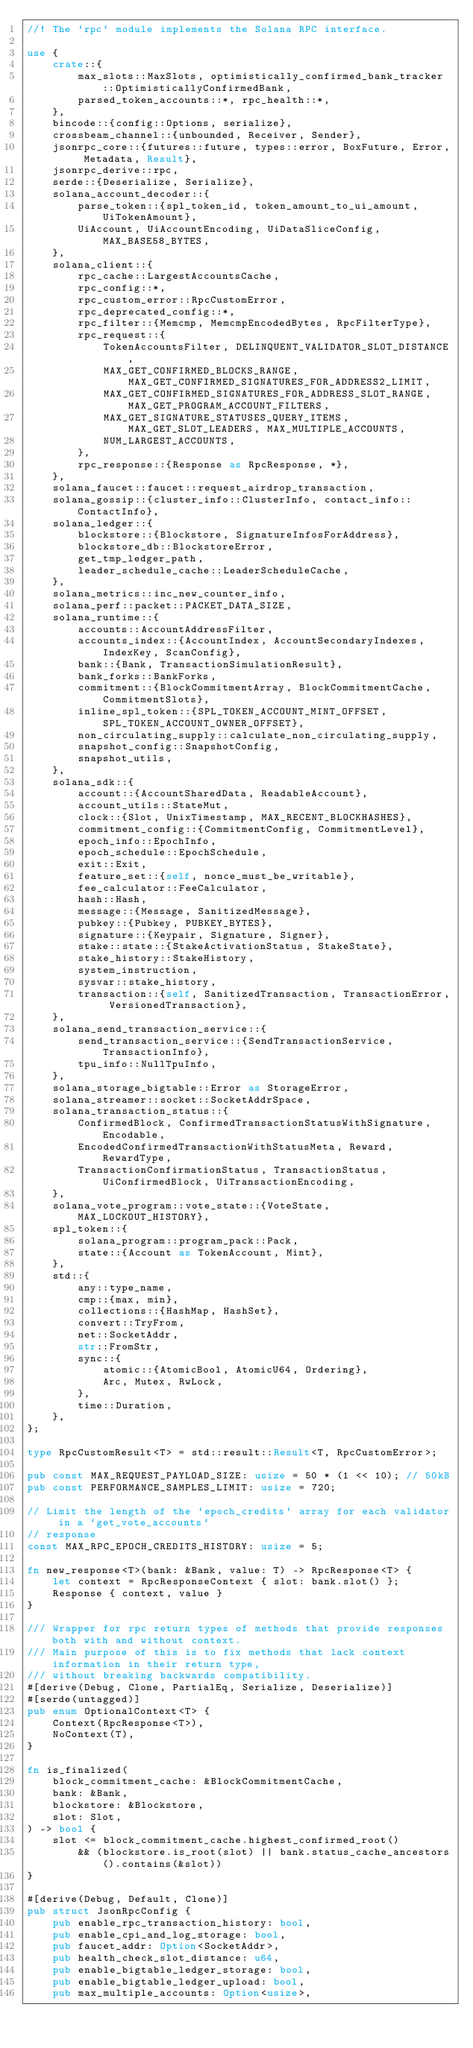Convert code to text. <code><loc_0><loc_0><loc_500><loc_500><_Rust_>//! The `rpc` module implements the Solana RPC interface.

use {
    crate::{
        max_slots::MaxSlots, optimistically_confirmed_bank_tracker::OptimisticallyConfirmedBank,
        parsed_token_accounts::*, rpc_health::*,
    },
    bincode::{config::Options, serialize},
    crossbeam_channel::{unbounded, Receiver, Sender},
    jsonrpc_core::{futures::future, types::error, BoxFuture, Error, Metadata, Result},
    jsonrpc_derive::rpc,
    serde::{Deserialize, Serialize},
    solana_account_decoder::{
        parse_token::{spl_token_id, token_amount_to_ui_amount, UiTokenAmount},
        UiAccount, UiAccountEncoding, UiDataSliceConfig, MAX_BASE58_BYTES,
    },
    solana_client::{
        rpc_cache::LargestAccountsCache,
        rpc_config::*,
        rpc_custom_error::RpcCustomError,
        rpc_deprecated_config::*,
        rpc_filter::{Memcmp, MemcmpEncodedBytes, RpcFilterType},
        rpc_request::{
            TokenAccountsFilter, DELINQUENT_VALIDATOR_SLOT_DISTANCE,
            MAX_GET_CONFIRMED_BLOCKS_RANGE, MAX_GET_CONFIRMED_SIGNATURES_FOR_ADDRESS2_LIMIT,
            MAX_GET_CONFIRMED_SIGNATURES_FOR_ADDRESS_SLOT_RANGE, MAX_GET_PROGRAM_ACCOUNT_FILTERS,
            MAX_GET_SIGNATURE_STATUSES_QUERY_ITEMS, MAX_GET_SLOT_LEADERS, MAX_MULTIPLE_ACCOUNTS,
            NUM_LARGEST_ACCOUNTS,
        },
        rpc_response::{Response as RpcResponse, *},
    },
    solana_faucet::faucet::request_airdrop_transaction,
    solana_gossip::{cluster_info::ClusterInfo, contact_info::ContactInfo},
    solana_ledger::{
        blockstore::{Blockstore, SignatureInfosForAddress},
        blockstore_db::BlockstoreError,
        get_tmp_ledger_path,
        leader_schedule_cache::LeaderScheduleCache,
    },
    solana_metrics::inc_new_counter_info,
    solana_perf::packet::PACKET_DATA_SIZE,
    solana_runtime::{
        accounts::AccountAddressFilter,
        accounts_index::{AccountIndex, AccountSecondaryIndexes, IndexKey, ScanConfig},
        bank::{Bank, TransactionSimulationResult},
        bank_forks::BankForks,
        commitment::{BlockCommitmentArray, BlockCommitmentCache, CommitmentSlots},
        inline_spl_token::{SPL_TOKEN_ACCOUNT_MINT_OFFSET, SPL_TOKEN_ACCOUNT_OWNER_OFFSET},
        non_circulating_supply::calculate_non_circulating_supply,
        snapshot_config::SnapshotConfig,
        snapshot_utils,
    },
    solana_sdk::{
        account::{AccountSharedData, ReadableAccount},
        account_utils::StateMut,
        clock::{Slot, UnixTimestamp, MAX_RECENT_BLOCKHASHES},
        commitment_config::{CommitmentConfig, CommitmentLevel},
        epoch_info::EpochInfo,
        epoch_schedule::EpochSchedule,
        exit::Exit,
        feature_set::{self, nonce_must_be_writable},
        fee_calculator::FeeCalculator,
        hash::Hash,
        message::{Message, SanitizedMessage},
        pubkey::{Pubkey, PUBKEY_BYTES},
        signature::{Keypair, Signature, Signer},
        stake::state::{StakeActivationStatus, StakeState},
        stake_history::StakeHistory,
        system_instruction,
        sysvar::stake_history,
        transaction::{self, SanitizedTransaction, TransactionError, VersionedTransaction},
    },
    solana_send_transaction_service::{
        send_transaction_service::{SendTransactionService, TransactionInfo},
        tpu_info::NullTpuInfo,
    },
    solana_storage_bigtable::Error as StorageError,
    solana_streamer::socket::SocketAddrSpace,
    solana_transaction_status::{
        ConfirmedBlock, ConfirmedTransactionStatusWithSignature, Encodable,
        EncodedConfirmedTransactionWithStatusMeta, Reward, RewardType,
        TransactionConfirmationStatus, TransactionStatus, UiConfirmedBlock, UiTransactionEncoding,
    },
    solana_vote_program::vote_state::{VoteState, MAX_LOCKOUT_HISTORY},
    spl_token::{
        solana_program::program_pack::Pack,
        state::{Account as TokenAccount, Mint},
    },
    std::{
        any::type_name,
        cmp::{max, min},
        collections::{HashMap, HashSet},
        convert::TryFrom,
        net::SocketAddr,
        str::FromStr,
        sync::{
            atomic::{AtomicBool, AtomicU64, Ordering},
            Arc, Mutex, RwLock,
        },
        time::Duration,
    },
};

type RpcCustomResult<T> = std::result::Result<T, RpcCustomError>;

pub const MAX_REQUEST_PAYLOAD_SIZE: usize = 50 * (1 << 10); // 50kB
pub const PERFORMANCE_SAMPLES_LIMIT: usize = 720;

// Limit the length of the `epoch_credits` array for each validator in a `get_vote_accounts`
// response
const MAX_RPC_EPOCH_CREDITS_HISTORY: usize = 5;

fn new_response<T>(bank: &Bank, value: T) -> RpcResponse<T> {
    let context = RpcResponseContext { slot: bank.slot() };
    Response { context, value }
}

/// Wrapper for rpc return types of methods that provide responses both with and without context.
/// Main purpose of this is to fix methods that lack context information in their return type,
/// without breaking backwards compatibility.
#[derive(Debug, Clone, PartialEq, Serialize, Deserialize)]
#[serde(untagged)]
pub enum OptionalContext<T> {
    Context(RpcResponse<T>),
    NoContext(T),
}

fn is_finalized(
    block_commitment_cache: &BlockCommitmentCache,
    bank: &Bank,
    blockstore: &Blockstore,
    slot: Slot,
) -> bool {
    slot <= block_commitment_cache.highest_confirmed_root()
        && (blockstore.is_root(slot) || bank.status_cache_ancestors().contains(&slot))
}

#[derive(Debug, Default, Clone)]
pub struct JsonRpcConfig {
    pub enable_rpc_transaction_history: bool,
    pub enable_cpi_and_log_storage: bool,
    pub faucet_addr: Option<SocketAddr>,
    pub health_check_slot_distance: u64,
    pub enable_bigtable_ledger_storage: bool,
    pub enable_bigtable_ledger_upload: bool,
    pub max_multiple_accounts: Option<usize>,</code> 